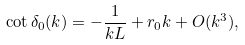Convert formula to latex. <formula><loc_0><loc_0><loc_500><loc_500>\cot \delta _ { 0 } ( k ) = - \frac { 1 } { k L } + r _ { 0 } k + O ( k ^ { 3 } ) ,</formula> 